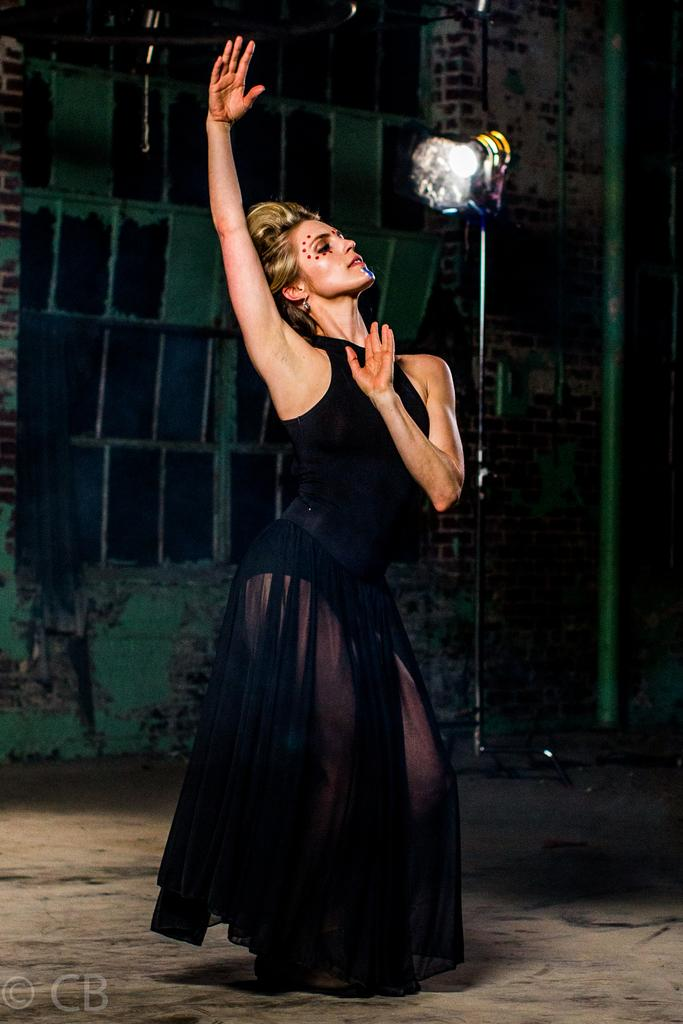Who is the main subject in the image? There is a girl in the image. What is the girl doing in the image? The girl is standing on the floor and raising her hand. What can be seen in front of the girl? There is a light in front of the girl. What is visible in the background of the image? There is a wall in the background of the image. What type of stove is visible in the image? There is no stove present in the image. Is the girl sleeping in the image? No, the girl is standing and raising her hand, so she is not sleeping. 